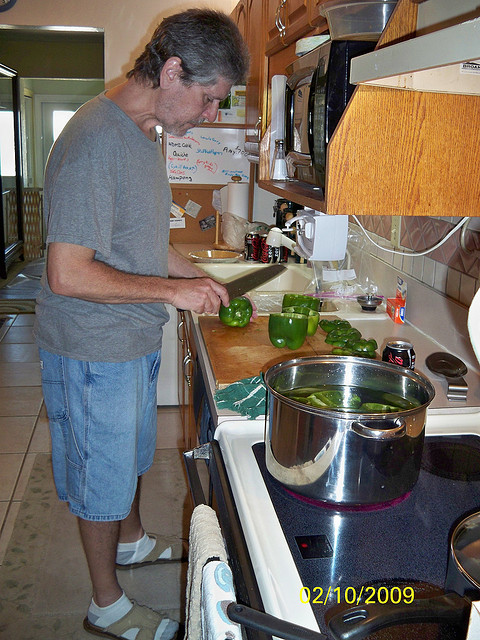Read all the text in this image. 02/10/2009 